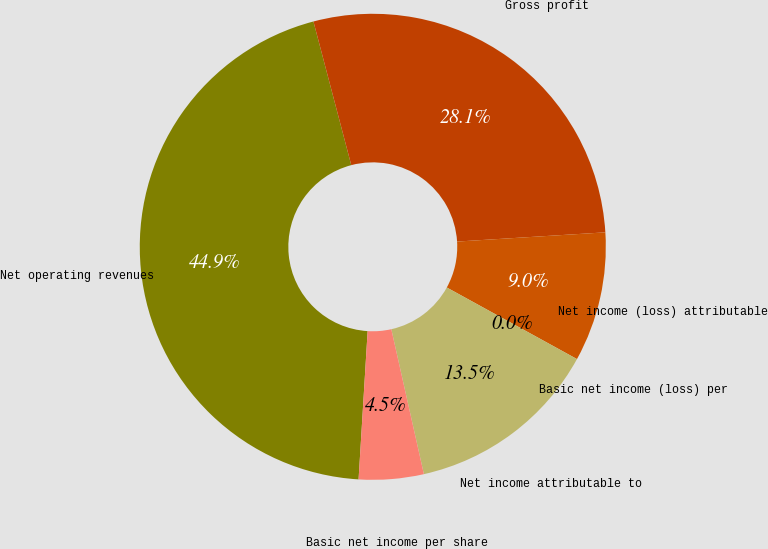Convert chart. <chart><loc_0><loc_0><loc_500><loc_500><pie_chart><fcel>Net operating revenues<fcel>Gross profit<fcel>Net income (loss) attributable<fcel>Basic net income (loss) per<fcel>Net income attributable to<fcel>Basic net income per share<nl><fcel>44.93%<fcel>28.11%<fcel>8.99%<fcel>0.0%<fcel>13.48%<fcel>4.49%<nl></chart> 